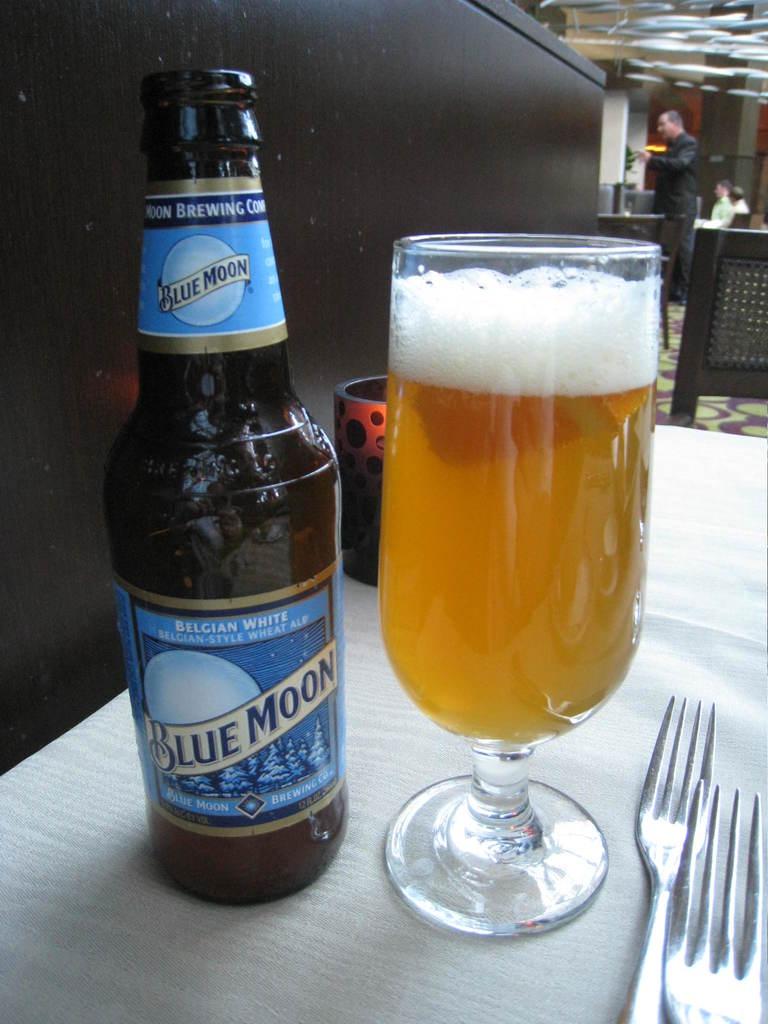What variety of blue moon is in the glass?
Offer a very short reply. Belgian white. Was this made by a brewing company?
Your response must be concise. Yes. 